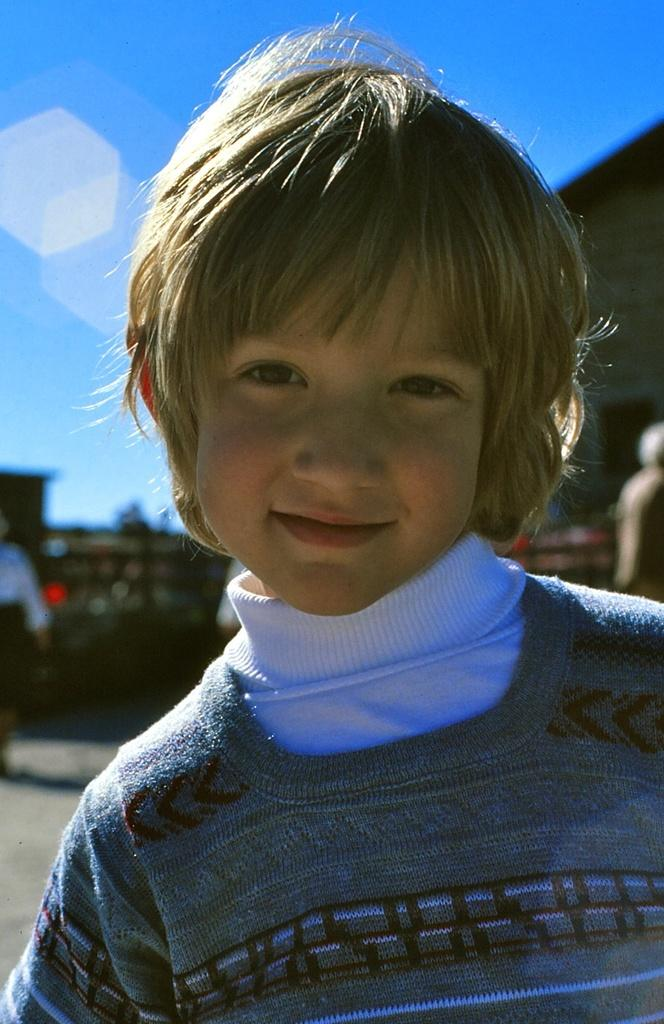Who is the main subject in the image? There is a boy in the image. What can be seen in the background of the image? There is a group of people and buildings in the background of the image. What is visible at the top of the image? The sky is visible at the top of the image. How does the cave increase in size during the day in the image? There is no cave present in the image, so it cannot increase in size during the day. 